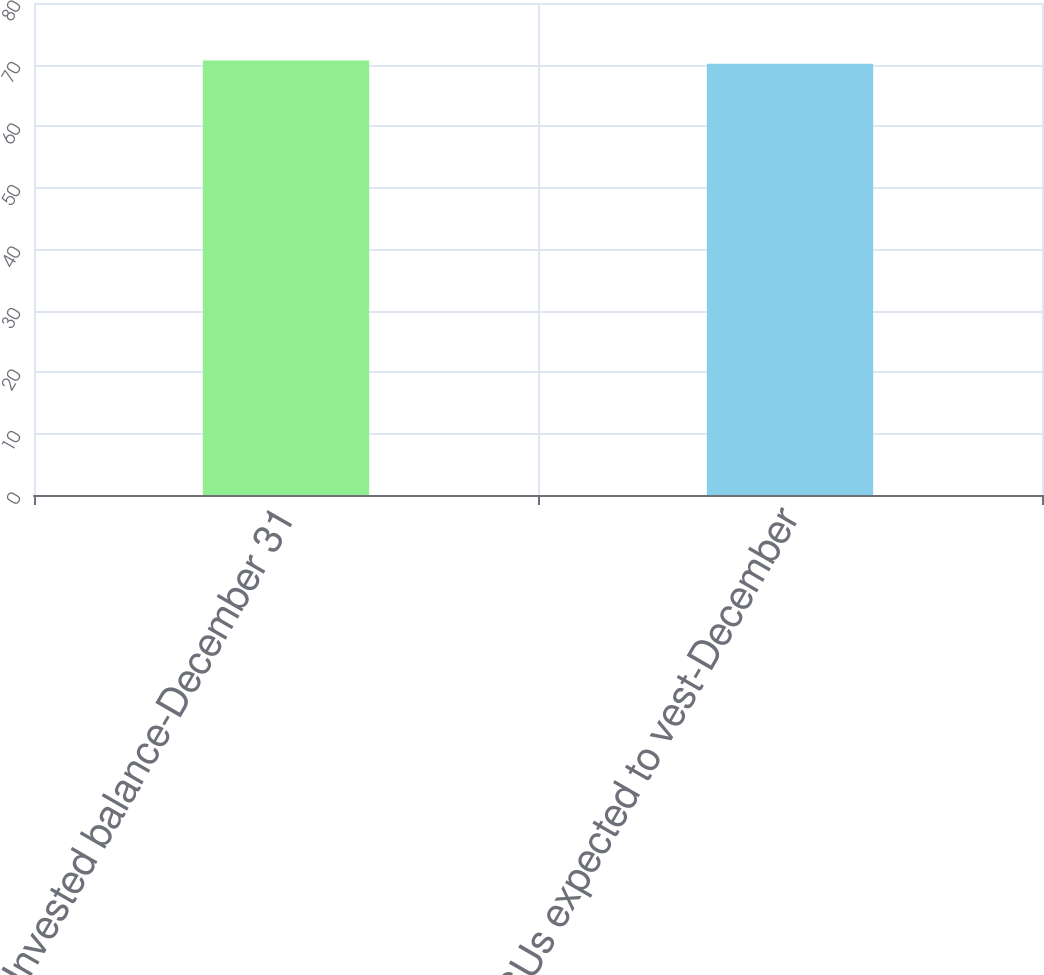<chart> <loc_0><loc_0><loc_500><loc_500><bar_chart><fcel>Unvested balance-December 31<fcel>RSUs expected to vest-December<nl><fcel>70.66<fcel>70.11<nl></chart> 